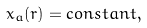<formula> <loc_0><loc_0><loc_500><loc_500>x _ { a } ( r ) = c o n s t a n t ,</formula> 